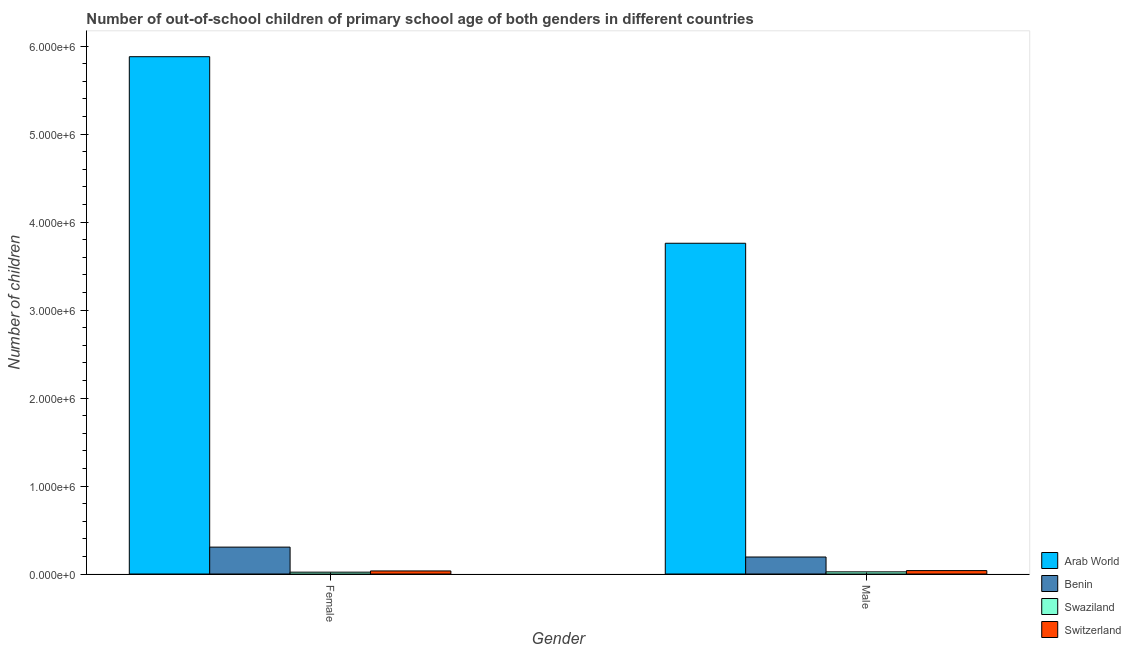How many different coloured bars are there?
Provide a succinct answer. 4. Are the number of bars on each tick of the X-axis equal?
Your response must be concise. Yes. How many bars are there on the 1st tick from the right?
Ensure brevity in your answer.  4. What is the label of the 2nd group of bars from the left?
Offer a very short reply. Male. What is the number of male out-of-school students in Benin?
Your answer should be very brief. 1.93e+05. Across all countries, what is the maximum number of female out-of-school students?
Offer a terse response. 5.88e+06. Across all countries, what is the minimum number of female out-of-school students?
Keep it short and to the point. 2.09e+04. In which country was the number of female out-of-school students maximum?
Make the answer very short. Arab World. In which country was the number of female out-of-school students minimum?
Offer a terse response. Swaziland. What is the total number of male out-of-school students in the graph?
Make the answer very short. 4.02e+06. What is the difference between the number of male out-of-school students in Benin and that in Arab World?
Your answer should be very brief. -3.57e+06. What is the difference between the number of female out-of-school students in Benin and the number of male out-of-school students in Swaziland?
Keep it short and to the point. 2.81e+05. What is the average number of male out-of-school students per country?
Ensure brevity in your answer.  1.00e+06. What is the difference between the number of female out-of-school students and number of male out-of-school students in Arab World?
Provide a succinct answer. 2.12e+06. In how many countries, is the number of female out-of-school students greater than 800000 ?
Your answer should be compact. 1. What is the ratio of the number of male out-of-school students in Benin to that in Arab World?
Make the answer very short. 0.05. In how many countries, is the number of female out-of-school students greater than the average number of female out-of-school students taken over all countries?
Your answer should be compact. 1. What does the 1st bar from the left in Male represents?
Provide a succinct answer. Arab World. What does the 3rd bar from the right in Male represents?
Offer a very short reply. Benin. How many bars are there?
Offer a terse response. 8. How many countries are there in the graph?
Provide a succinct answer. 4. Does the graph contain any zero values?
Offer a very short reply. No. Does the graph contain grids?
Offer a very short reply. No. Where does the legend appear in the graph?
Offer a very short reply. Bottom right. How many legend labels are there?
Offer a very short reply. 4. How are the legend labels stacked?
Your answer should be very brief. Vertical. What is the title of the graph?
Make the answer very short. Number of out-of-school children of primary school age of both genders in different countries. Does "Monaco" appear as one of the legend labels in the graph?
Give a very brief answer. No. What is the label or title of the X-axis?
Provide a short and direct response. Gender. What is the label or title of the Y-axis?
Provide a succinct answer. Number of children. What is the Number of children of Arab World in Female?
Offer a terse response. 5.88e+06. What is the Number of children in Benin in Female?
Offer a very short reply. 3.06e+05. What is the Number of children in Swaziland in Female?
Offer a terse response. 2.09e+04. What is the Number of children in Switzerland in Female?
Offer a terse response. 3.48e+04. What is the Number of children of Arab World in Male?
Your response must be concise. 3.76e+06. What is the Number of children in Benin in Male?
Offer a terse response. 1.93e+05. What is the Number of children in Swaziland in Male?
Offer a terse response. 2.45e+04. What is the Number of children in Switzerland in Male?
Make the answer very short. 3.87e+04. Across all Gender, what is the maximum Number of children in Arab World?
Offer a very short reply. 5.88e+06. Across all Gender, what is the maximum Number of children of Benin?
Offer a terse response. 3.06e+05. Across all Gender, what is the maximum Number of children of Swaziland?
Your answer should be very brief. 2.45e+04. Across all Gender, what is the maximum Number of children in Switzerland?
Provide a succinct answer. 3.87e+04. Across all Gender, what is the minimum Number of children in Arab World?
Provide a short and direct response. 3.76e+06. Across all Gender, what is the minimum Number of children of Benin?
Offer a terse response. 1.93e+05. Across all Gender, what is the minimum Number of children of Swaziland?
Provide a succinct answer. 2.09e+04. Across all Gender, what is the minimum Number of children in Switzerland?
Make the answer very short. 3.48e+04. What is the total Number of children of Arab World in the graph?
Your response must be concise. 9.64e+06. What is the total Number of children of Benin in the graph?
Provide a short and direct response. 4.99e+05. What is the total Number of children in Swaziland in the graph?
Make the answer very short. 4.55e+04. What is the total Number of children of Switzerland in the graph?
Make the answer very short. 7.35e+04. What is the difference between the Number of children in Arab World in Female and that in Male?
Give a very brief answer. 2.12e+06. What is the difference between the Number of children of Benin in Female and that in Male?
Ensure brevity in your answer.  1.12e+05. What is the difference between the Number of children in Swaziland in Female and that in Male?
Provide a succinct answer. -3596. What is the difference between the Number of children in Switzerland in Female and that in Male?
Offer a terse response. -3879. What is the difference between the Number of children in Arab World in Female and the Number of children in Benin in Male?
Offer a terse response. 5.69e+06. What is the difference between the Number of children of Arab World in Female and the Number of children of Swaziland in Male?
Offer a terse response. 5.85e+06. What is the difference between the Number of children of Arab World in Female and the Number of children of Switzerland in Male?
Offer a terse response. 5.84e+06. What is the difference between the Number of children of Benin in Female and the Number of children of Swaziland in Male?
Your response must be concise. 2.81e+05. What is the difference between the Number of children of Benin in Female and the Number of children of Switzerland in Male?
Make the answer very short. 2.67e+05. What is the difference between the Number of children of Swaziland in Female and the Number of children of Switzerland in Male?
Your answer should be compact. -1.77e+04. What is the average Number of children in Arab World per Gender?
Offer a terse response. 4.82e+06. What is the average Number of children of Benin per Gender?
Give a very brief answer. 2.49e+05. What is the average Number of children of Swaziland per Gender?
Ensure brevity in your answer.  2.27e+04. What is the average Number of children in Switzerland per Gender?
Give a very brief answer. 3.67e+04. What is the difference between the Number of children of Arab World and Number of children of Benin in Female?
Ensure brevity in your answer.  5.57e+06. What is the difference between the Number of children of Arab World and Number of children of Swaziland in Female?
Make the answer very short. 5.86e+06. What is the difference between the Number of children of Arab World and Number of children of Switzerland in Female?
Your answer should be very brief. 5.84e+06. What is the difference between the Number of children of Benin and Number of children of Swaziland in Female?
Make the answer very short. 2.85e+05. What is the difference between the Number of children in Benin and Number of children in Switzerland in Female?
Your answer should be very brief. 2.71e+05. What is the difference between the Number of children of Swaziland and Number of children of Switzerland in Female?
Your answer should be very brief. -1.39e+04. What is the difference between the Number of children in Arab World and Number of children in Benin in Male?
Give a very brief answer. 3.57e+06. What is the difference between the Number of children in Arab World and Number of children in Swaziland in Male?
Give a very brief answer. 3.73e+06. What is the difference between the Number of children in Arab World and Number of children in Switzerland in Male?
Offer a very short reply. 3.72e+06. What is the difference between the Number of children of Benin and Number of children of Swaziland in Male?
Your answer should be very brief. 1.69e+05. What is the difference between the Number of children in Benin and Number of children in Switzerland in Male?
Provide a short and direct response. 1.55e+05. What is the difference between the Number of children of Swaziland and Number of children of Switzerland in Male?
Provide a short and direct response. -1.41e+04. What is the ratio of the Number of children in Arab World in Female to that in Male?
Offer a very short reply. 1.56. What is the ratio of the Number of children of Benin in Female to that in Male?
Your answer should be compact. 1.58. What is the ratio of the Number of children in Swaziland in Female to that in Male?
Ensure brevity in your answer.  0.85. What is the ratio of the Number of children in Switzerland in Female to that in Male?
Give a very brief answer. 0.9. What is the difference between the highest and the second highest Number of children of Arab World?
Make the answer very short. 2.12e+06. What is the difference between the highest and the second highest Number of children of Benin?
Offer a very short reply. 1.12e+05. What is the difference between the highest and the second highest Number of children in Swaziland?
Provide a short and direct response. 3596. What is the difference between the highest and the second highest Number of children of Switzerland?
Provide a succinct answer. 3879. What is the difference between the highest and the lowest Number of children in Arab World?
Give a very brief answer. 2.12e+06. What is the difference between the highest and the lowest Number of children in Benin?
Keep it short and to the point. 1.12e+05. What is the difference between the highest and the lowest Number of children of Swaziland?
Offer a very short reply. 3596. What is the difference between the highest and the lowest Number of children of Switzerland?
Your response must be concise. 3879. 